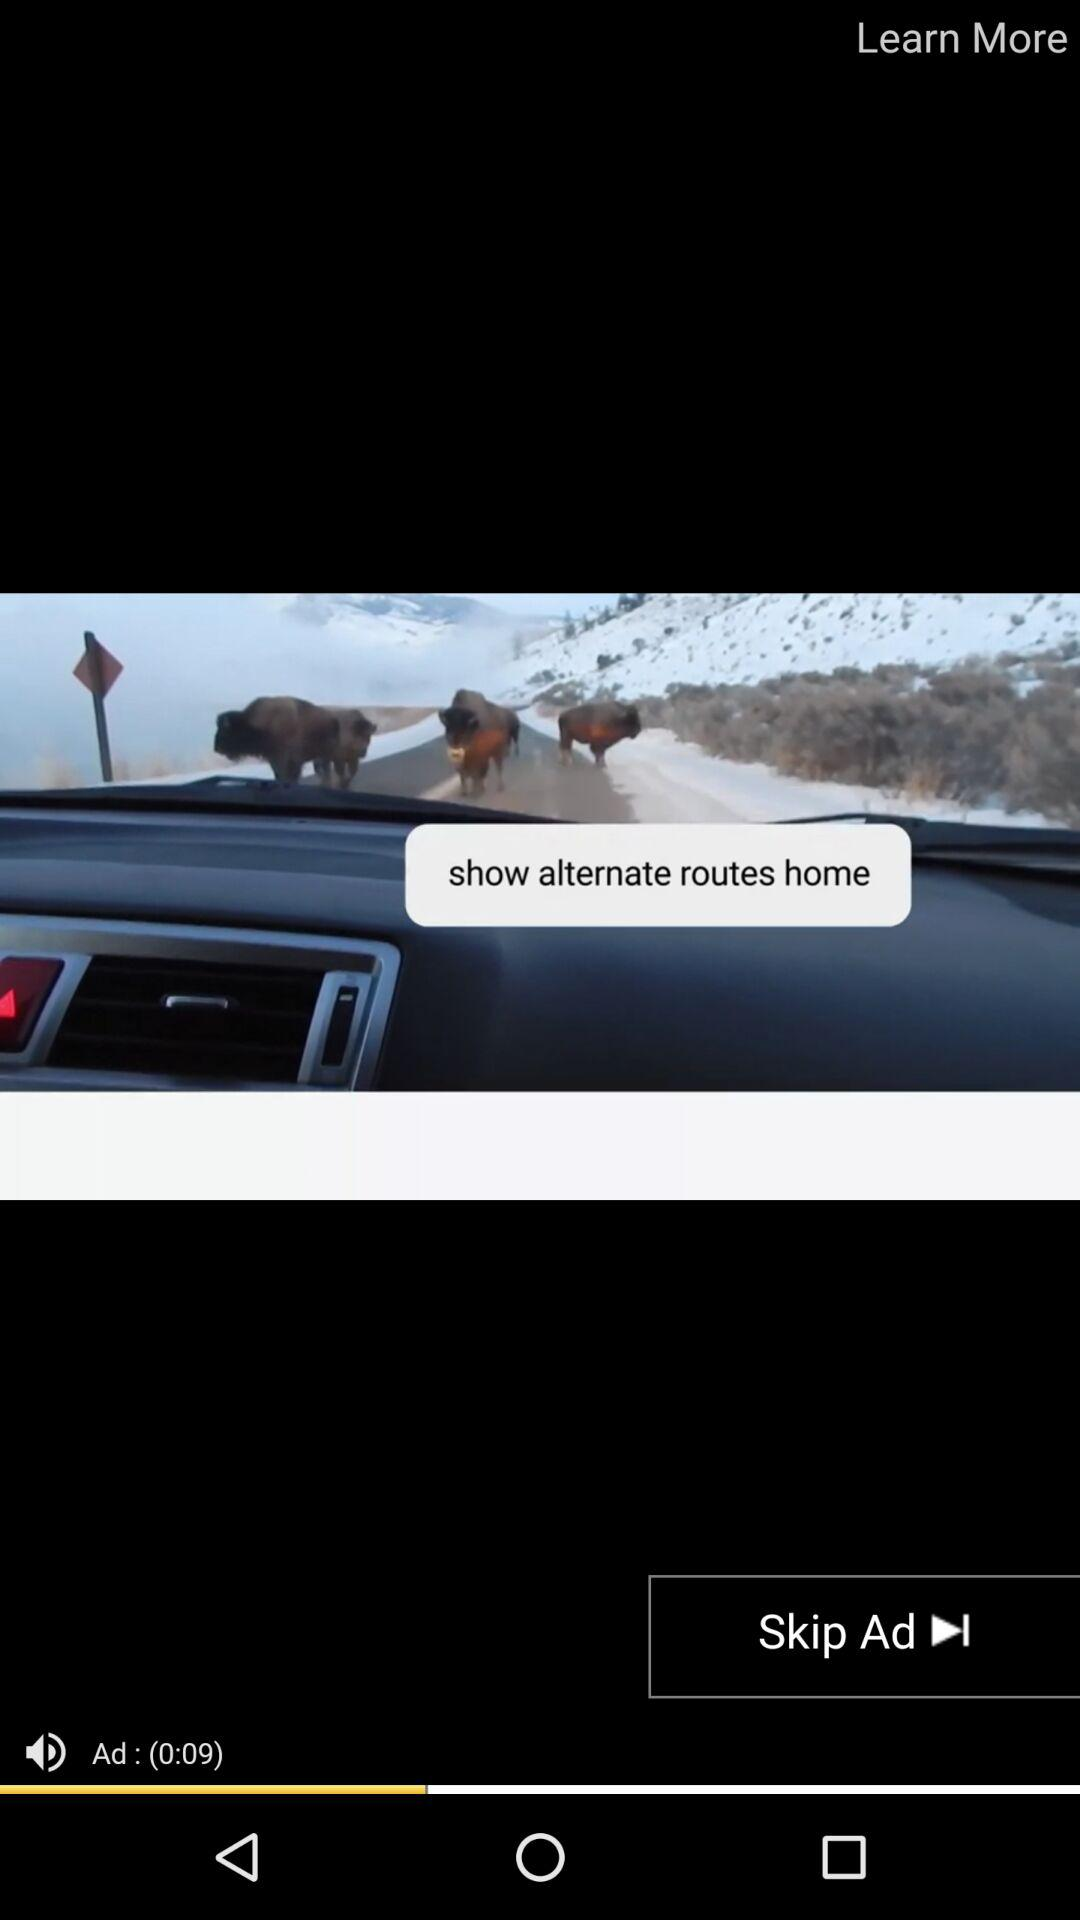How many seconds long is the ad?
Answer the question using a single word or phrase. 9 